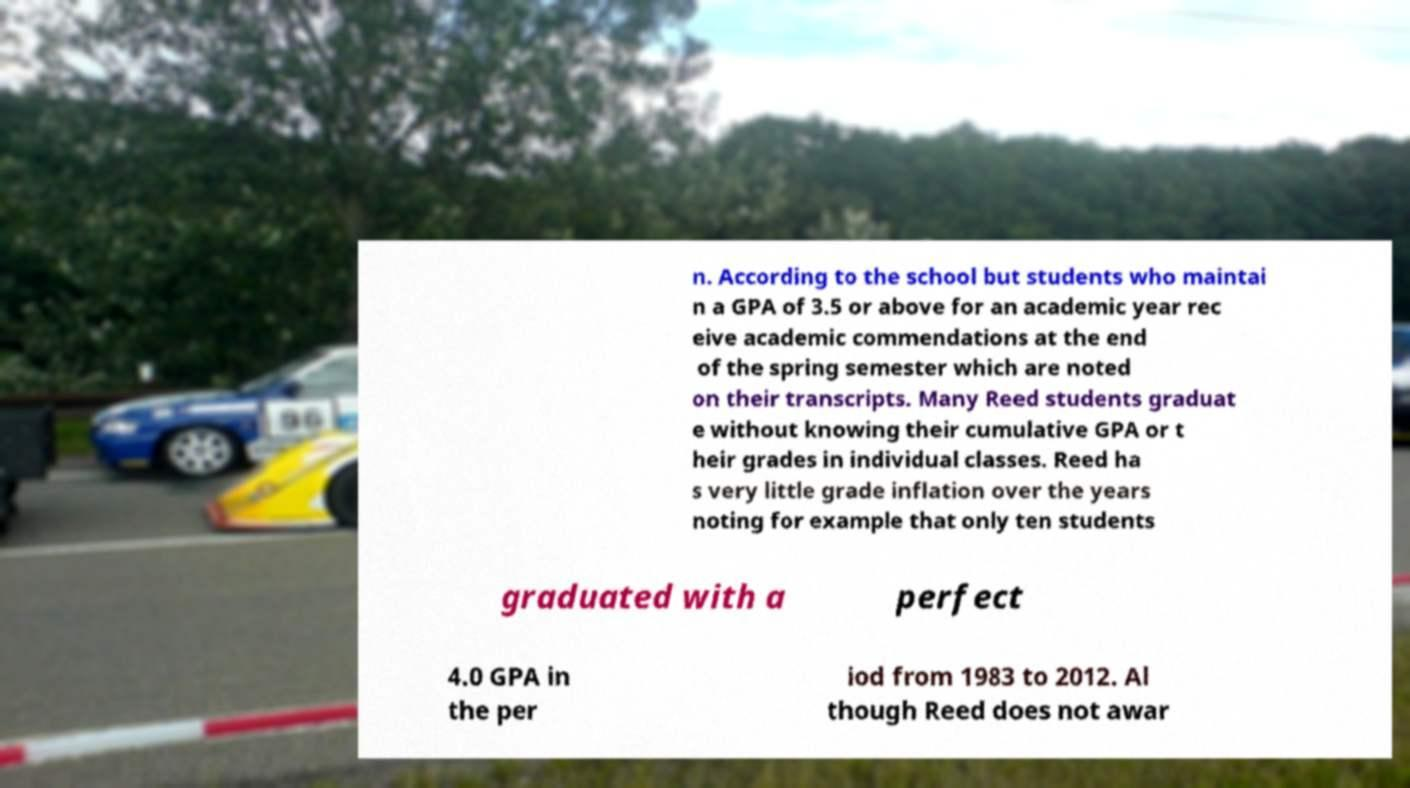For documentation purposes, I need the text within this image transcribed. Could you provide that? n. According to the school but students who maintai n a GPA of 3.5 or above for an academic year rec eive academic commendations at the end of the spring semester which are noted on their transcripts. Many Reed students graduat e without knowing their cumulative GPA or t heir grades in individual classes. Reed ha s very little grade inflation over the years noting for example that only ten students graduated with a perfect 4.0 GPA in the per iod from 1983 to 2012. Al though Reed does not awar 